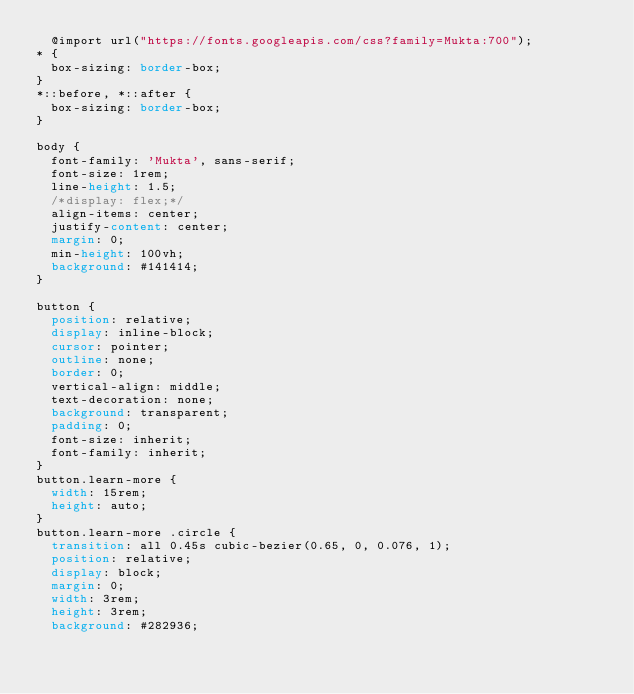Convert code to text. <code><loc_0><loc_0><loc_500><loc_500><_CSS_>	@import url("https://fonts.googleapis.com/css?family=Mukta:700");
* {
  box-sizing: border-box;
}
*::before, *::after {
  box-sizing: border-box;
}

body {
  font-family: 'Mukta', sans-serif;
  font-size: 1rem;
  line-height: 1.5;
  /*display: flex;*/
  align-items: center;
  justify-content: center;
  margin: 0;
  min-height: 100vh;
  background: #141414;
}

button {
  position: relative;
  display: inline-block;
  cursor: pointer;
  outline: none;
  border: 0;
  vertical-align: middle;
  text-decoration: none;
  background: transparent;
  padding: 0;
  font-size: inherit;
  font-family: inherit;
}
button.learn-more {
  width: 15rem;
  height: auto;
}
button.learn-more .circle {
  transition: all 0.45s cubic-bezier(0.65, 0, 0.076, 1);
  position: relative;
  display: block;
  margin: 0;
  width: 3rem;
  height: 3rem;
  background: #282936;</code> 